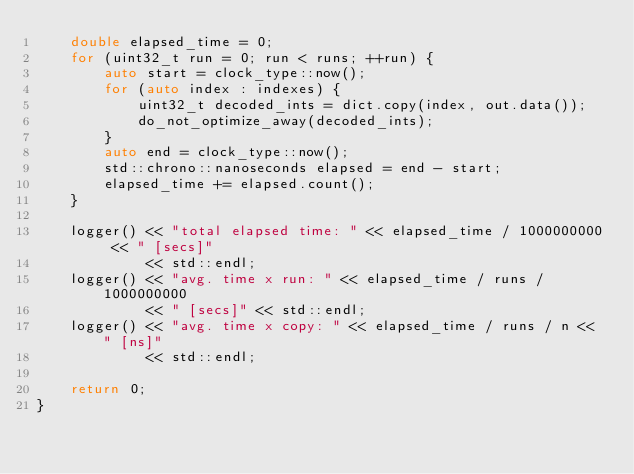<code> <loc_0><loc_0><loc_500><loc_500><_C++_>    double elapsed_time = 0;
    for (uint32_t run = 0; run < runs; ++run) {
        auto start = clock_type::now();
        for (auto index : indexes) {
            uint32_t decoded_ints = dict.copy(index, out.data());
            do_not_optimize_away(decoded_ints);
        }
        auto end = clock_type::now();
        std::chrono::nanoseconds elapsed = end - start;
        elapsed_time += elapsed.count();
    }

    logger() << "total elapsed time: " << elapsed_time / 1000000000 << " [secs]"
             << std::endl;
    logger() << "avg. time x run: " << elapsed_time / runs / 1000000000
             << " [secs]" << std::endl;
    logger() << "avg. time x copy: " << elapsed_time / runs / n << " [ns]"
             << std::endl;

    return 0;
}
</code> 